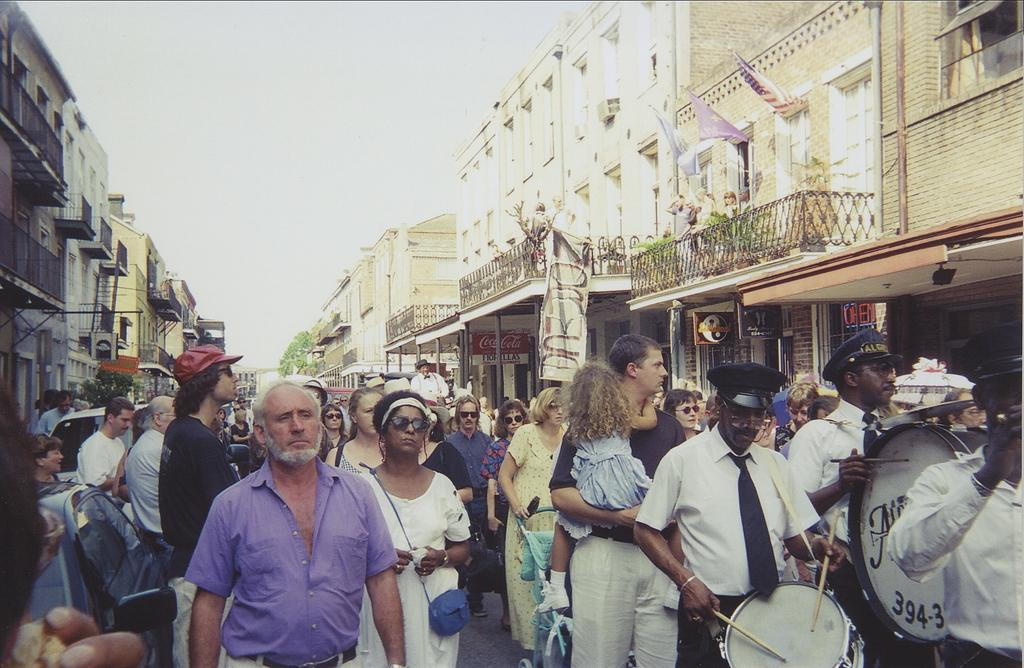What are the people in the image doing? The persons in the image are walking. Can you describe the activities of the persons on the right side of the image? Two persons on the right side of the image are holding musical instruments. What can be seen in the background of the image? There are buildings on either side of the image. How many horses are present in the image? There are no horses visible in the image. What type of skin condition can be seen on the persons in the image? There is no indication of any skin condition on the persons in the image. 